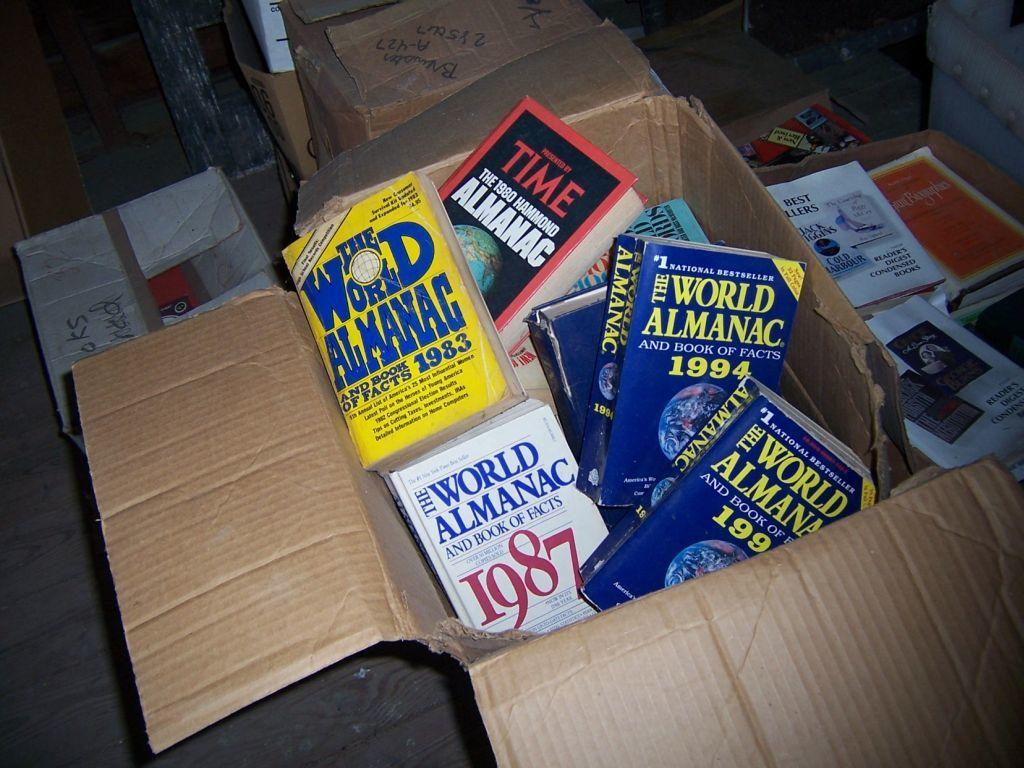<image>
Render a clear and concise summary of the photo. A box of old World Almanac books from the 80's and 90's. 